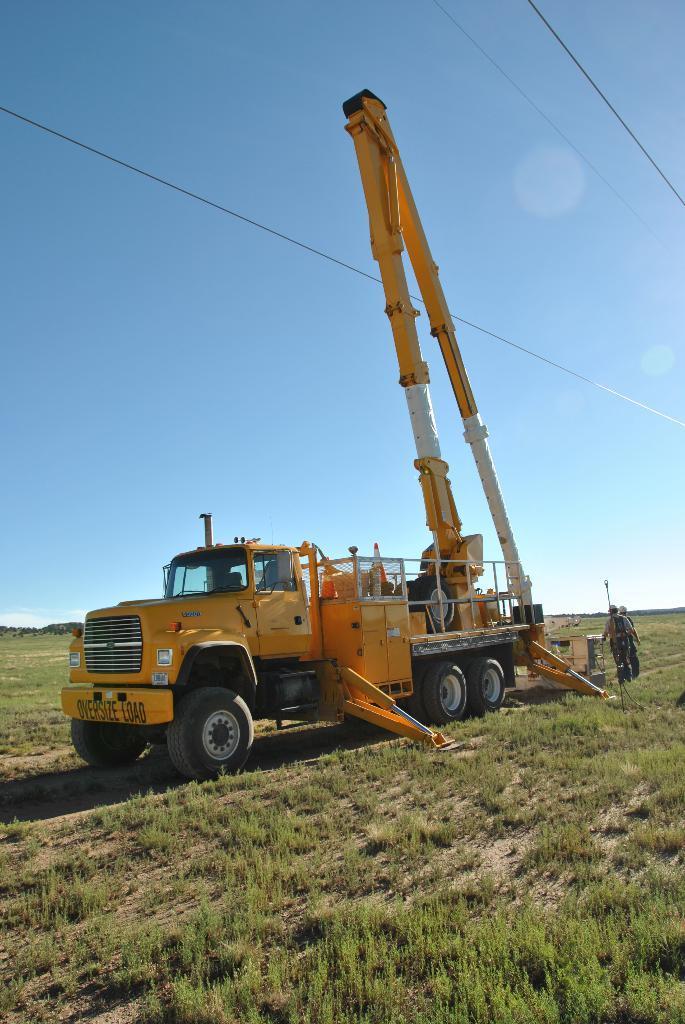Describe this image in one or two sentences. This picture shows a crane. It is yellow and white in color and we see few people standing on the ground and we see grass on the ground and a blue sky. 